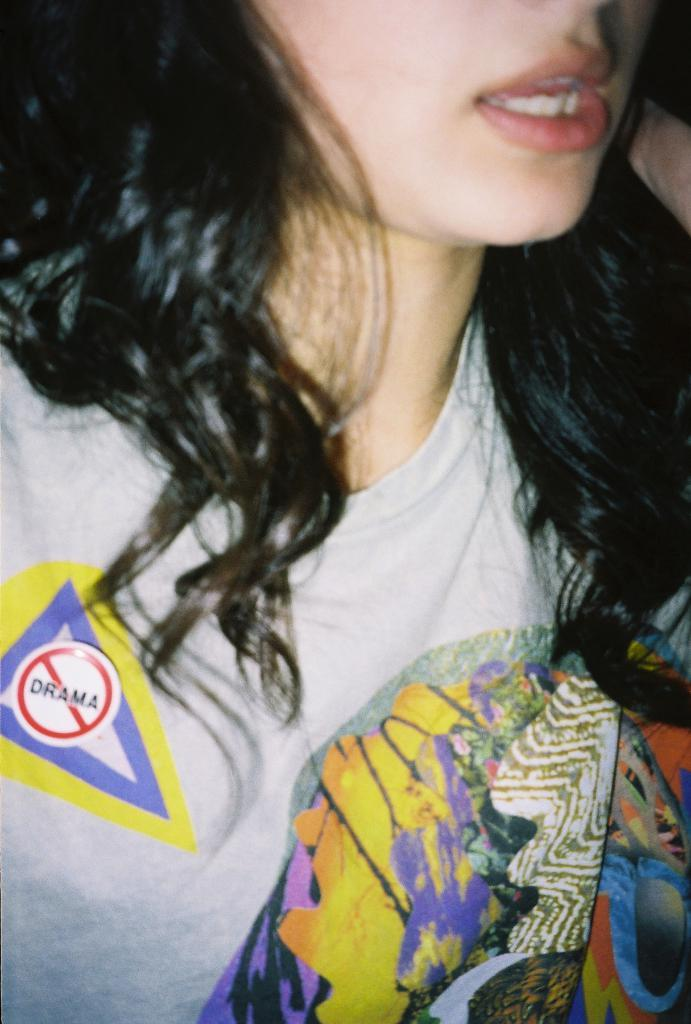Who is present in the image? There is a woman in the image. What is the woman wearing? The woman is wearing a t-shirt. What is written on the t-shirt? The word "Drama" is written on the t-shirt. What rule is the woman breaking in the image? There is no indication in the image that the woman is breaking any rules. Is the woman in jail in the image? There is: There is no indication in the image that the woman is in jail or has any association with a jail. 